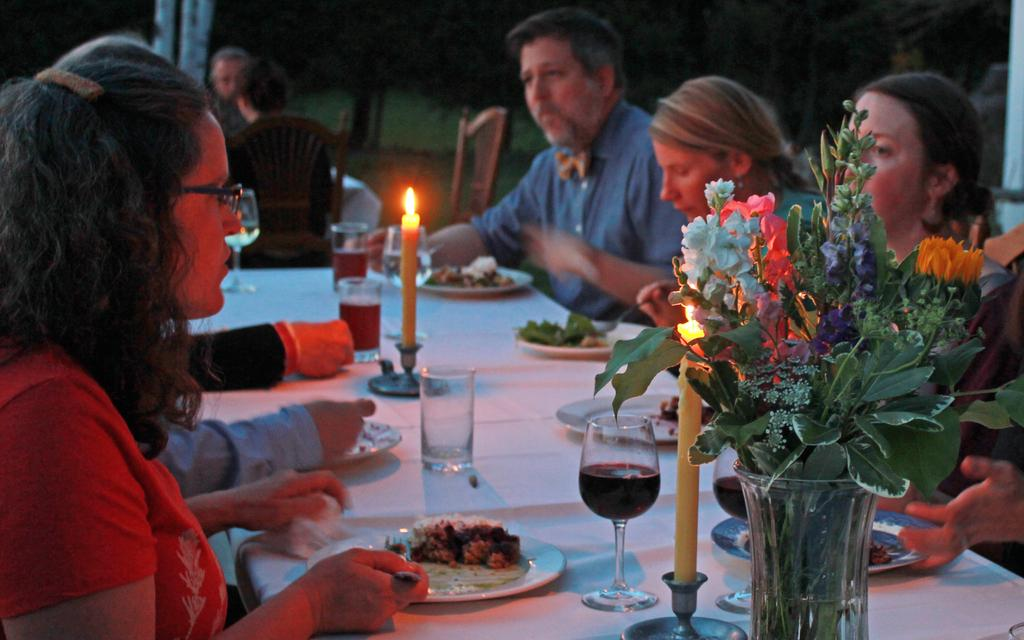What are the people in the image doing? The people in the image are sitting around a table. What objects can be seen on the table? There is a flask, a flower, glasses, plates, food, and a candle on the table. What might the people be using the glasses for? The glasses on the table might be used for drinking or serving beverages. What is the purpose of the candle on the table? The candle on the table might be used for lighting or decoration. What type of alarm is ringing in the image? There is no alarm present in the image. What decision are the people making in the image? The image does not depict a decision-making process; it simply shows people sitting around a table with various objects. 